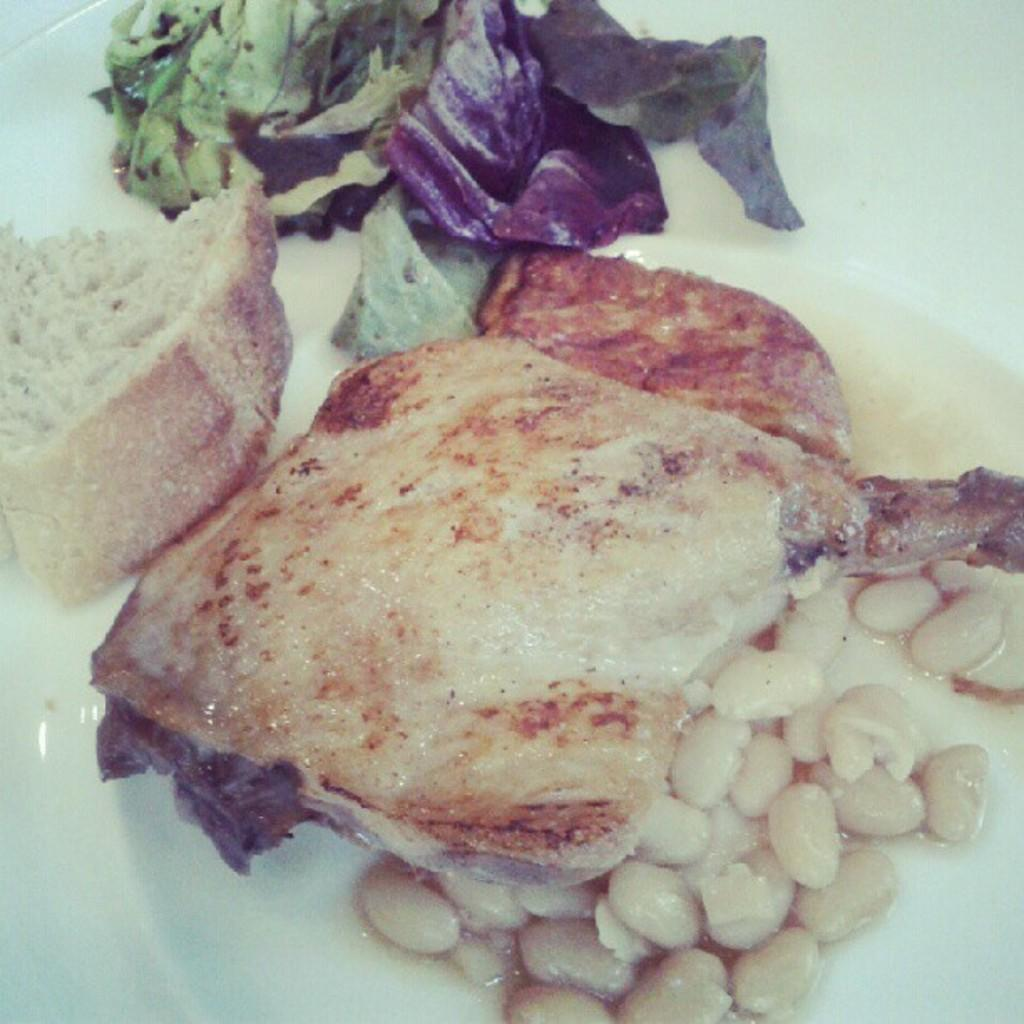What is the main subject on the plate in the image? There is a food item on a plate in the image. What type of invention is being used to drive the food item in the image? There is no invention or driving involved in the image; it simply shows a food item on a plate. 